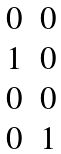Convert formula to latex. <formula><loc_0><loc_0><loc_500><loc_500>\begin{matrix} 0 & 0 \\ 1 & 0 \\ 0 & 0 \\ 0 & 1 \end{matrix}</formula> 